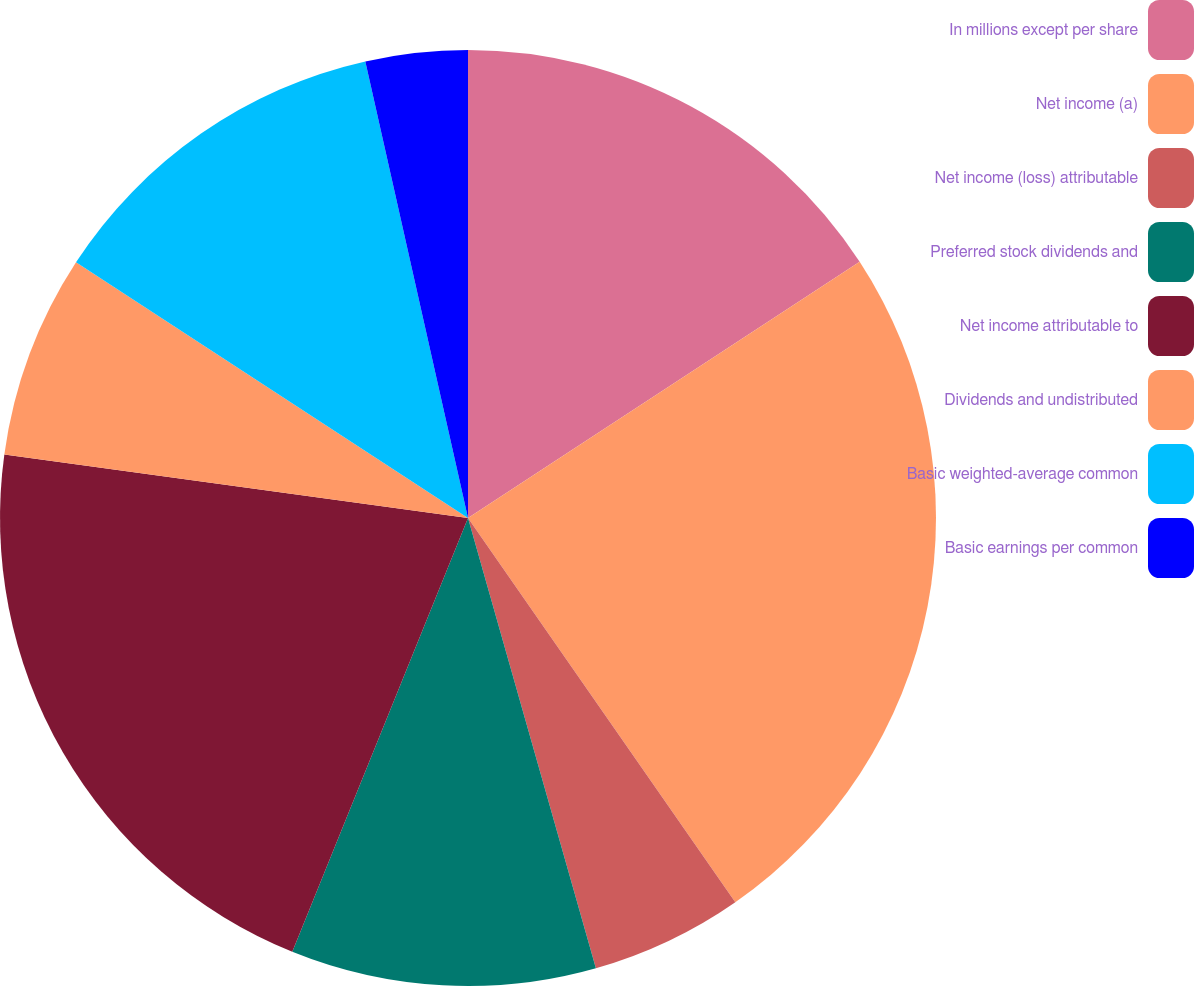Convert chart to OTSL. <chart><loc_0><loc_0><loc_500><loc_500><pie_chart><fcel>In millions except per share<fcel>Net income (a)<fcel>Net income (loss) attributable<fcel>Preferred stock dividends and<fcel>Net income attributable to<fcel>Dividends and undistributed<fcel>Basic weighted-average common<fcel>Basic earnings per common<nl><fcel>15.78%<fcel>24.54%<fcel>5.27%<fcel>10.53%<fcel>21.04%<fcel>7.03%<fcel>12.28%<fcel>3.52%<nl></chart> 